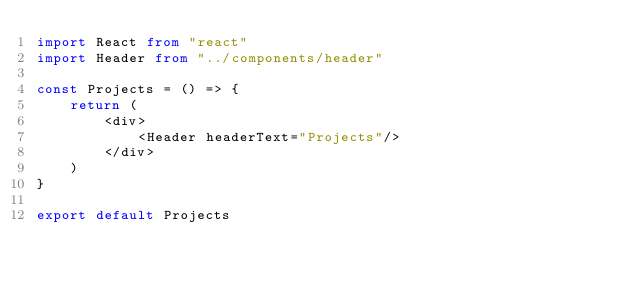Convert code to text. <code><loc_0><loc_0><loc_500><loc_500><_TypeScript_>import React from "react"
import Header from "../components/header"

const Projects = () => {
    return (
        <div>
            <Header headerText="Projects"/>
        </div>
    )
}

export default Projects
</code> 